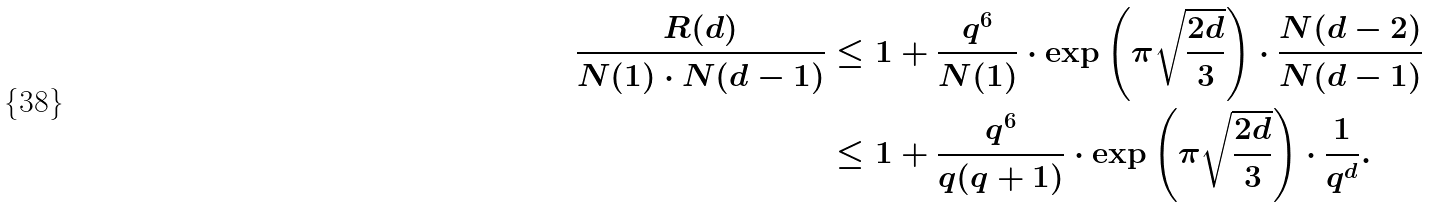Convert formula to latex. <formula><loc_0><loc_0><loc_500><loc_500>\frac { R ( d ) } { N ( 1 ) \cdot N ( d - 1 ) } & \leq 1 + \frac { q ^ { 6 } } { N ( 1 ) } \cdot \exp \left ( \pi \sqrt { \frac { 2 d } { 3 } } \right ) \cdot \frac { N ( d - 2 ) } { N ( d - 1 ) } \\ & \leq 1 + \frac { q ^ { 6 } } { q ( q + 1 ) } \cdot \exp \left ( \pi \sqrt { \frac { 2 d } { 3 } } \right ) \cdot \frac { 1 } { q ^ { d } } . \\</formula> 